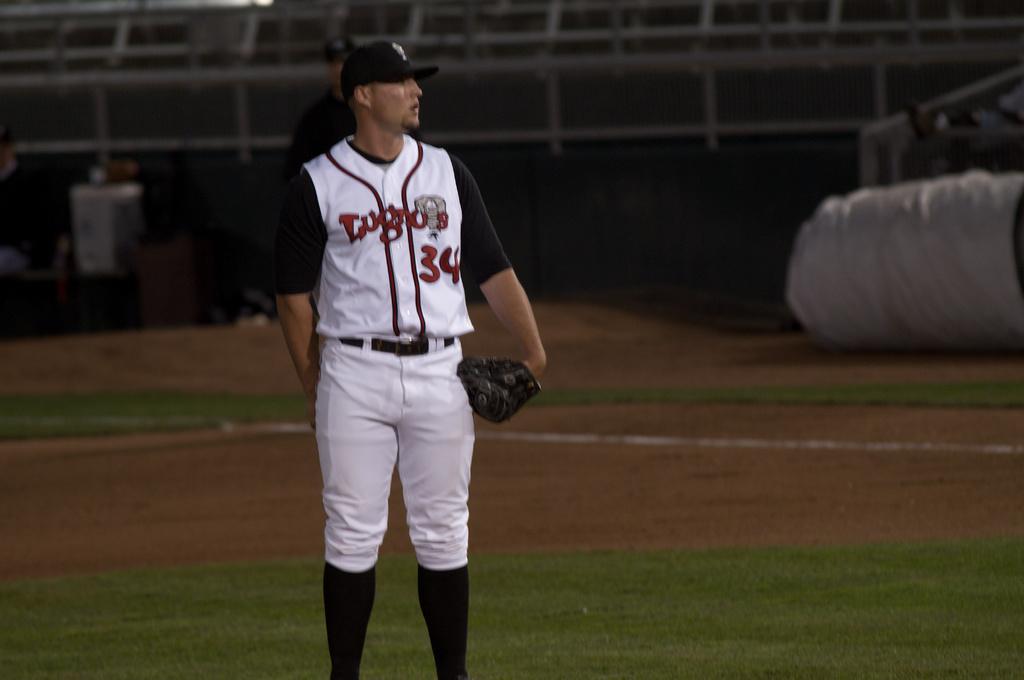How would you summarize this image in a sentence or two? In the image we can see a man standing, wearing clothes, cap, boot and gloves. Behind him there is another person, there is a grass, sand, white lines and a the background is blurred. 